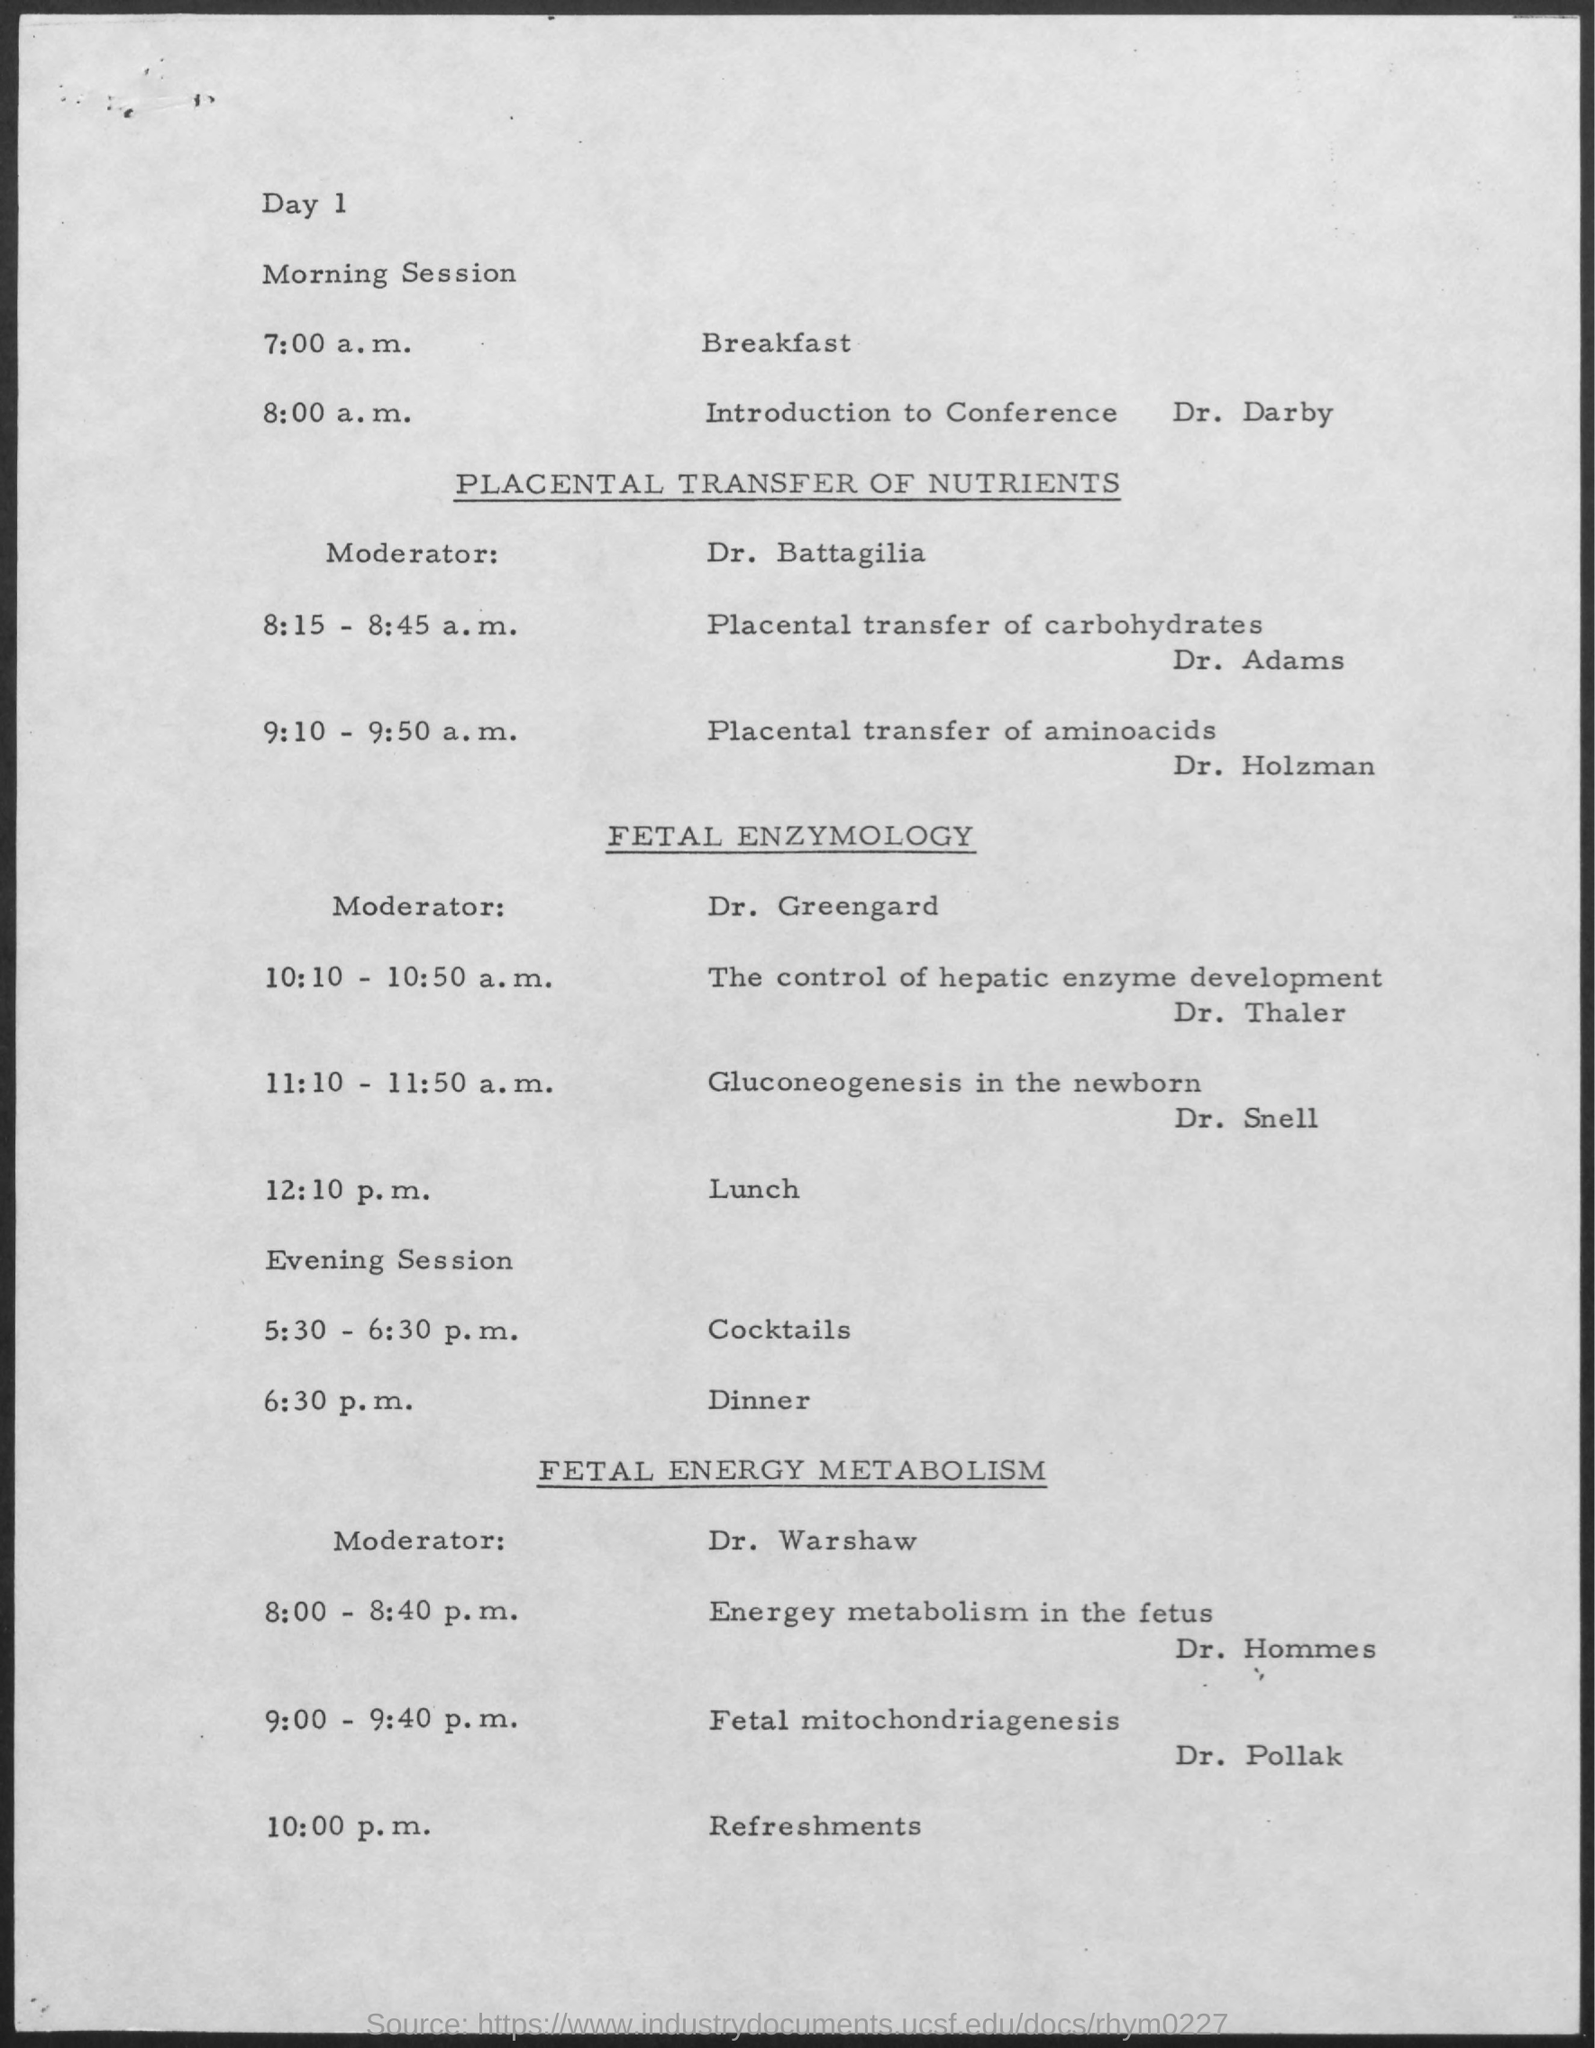Highlight a few significant elements in this photo. At 12:10 p.m., the schedule is as follows: Lunch will be taking place. Dr. Warshaw is the moderator for fetal energy metabolism. At 5:30-6:30 p.m., the schedule is as follows: cocktails will be served. At 8:00 a.m. on day 1 of the morning session, the schedule included an introduction to the conference by Dr. Darby. At 6:30 p.m., dinner will be served. 